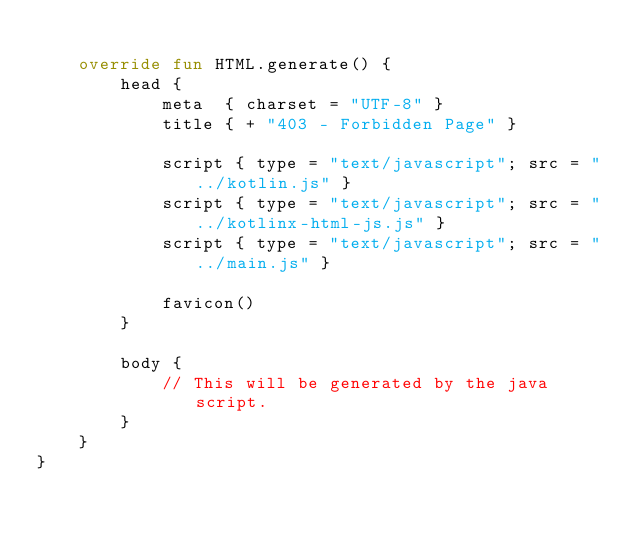Convert code to text. <code><loc_0><loc_0><loc_500><loc_500><_Kotlin_>
    override fun HTML.generate() {
        head {
            meta  { charset = "UTF-8" }
            title { + "403 - Forbidden Page" }

            script { type = "text/javascript"; src = "../kotlin.js" }
            script { type = "text/javascript"; src = "../kotlinx-html-js.js" }
            script { type = "text/javascript"; src = "../main.js" }

            favicon()
        }

        body {
            // This will be generated by the java script.
        }
    }
}</code> 